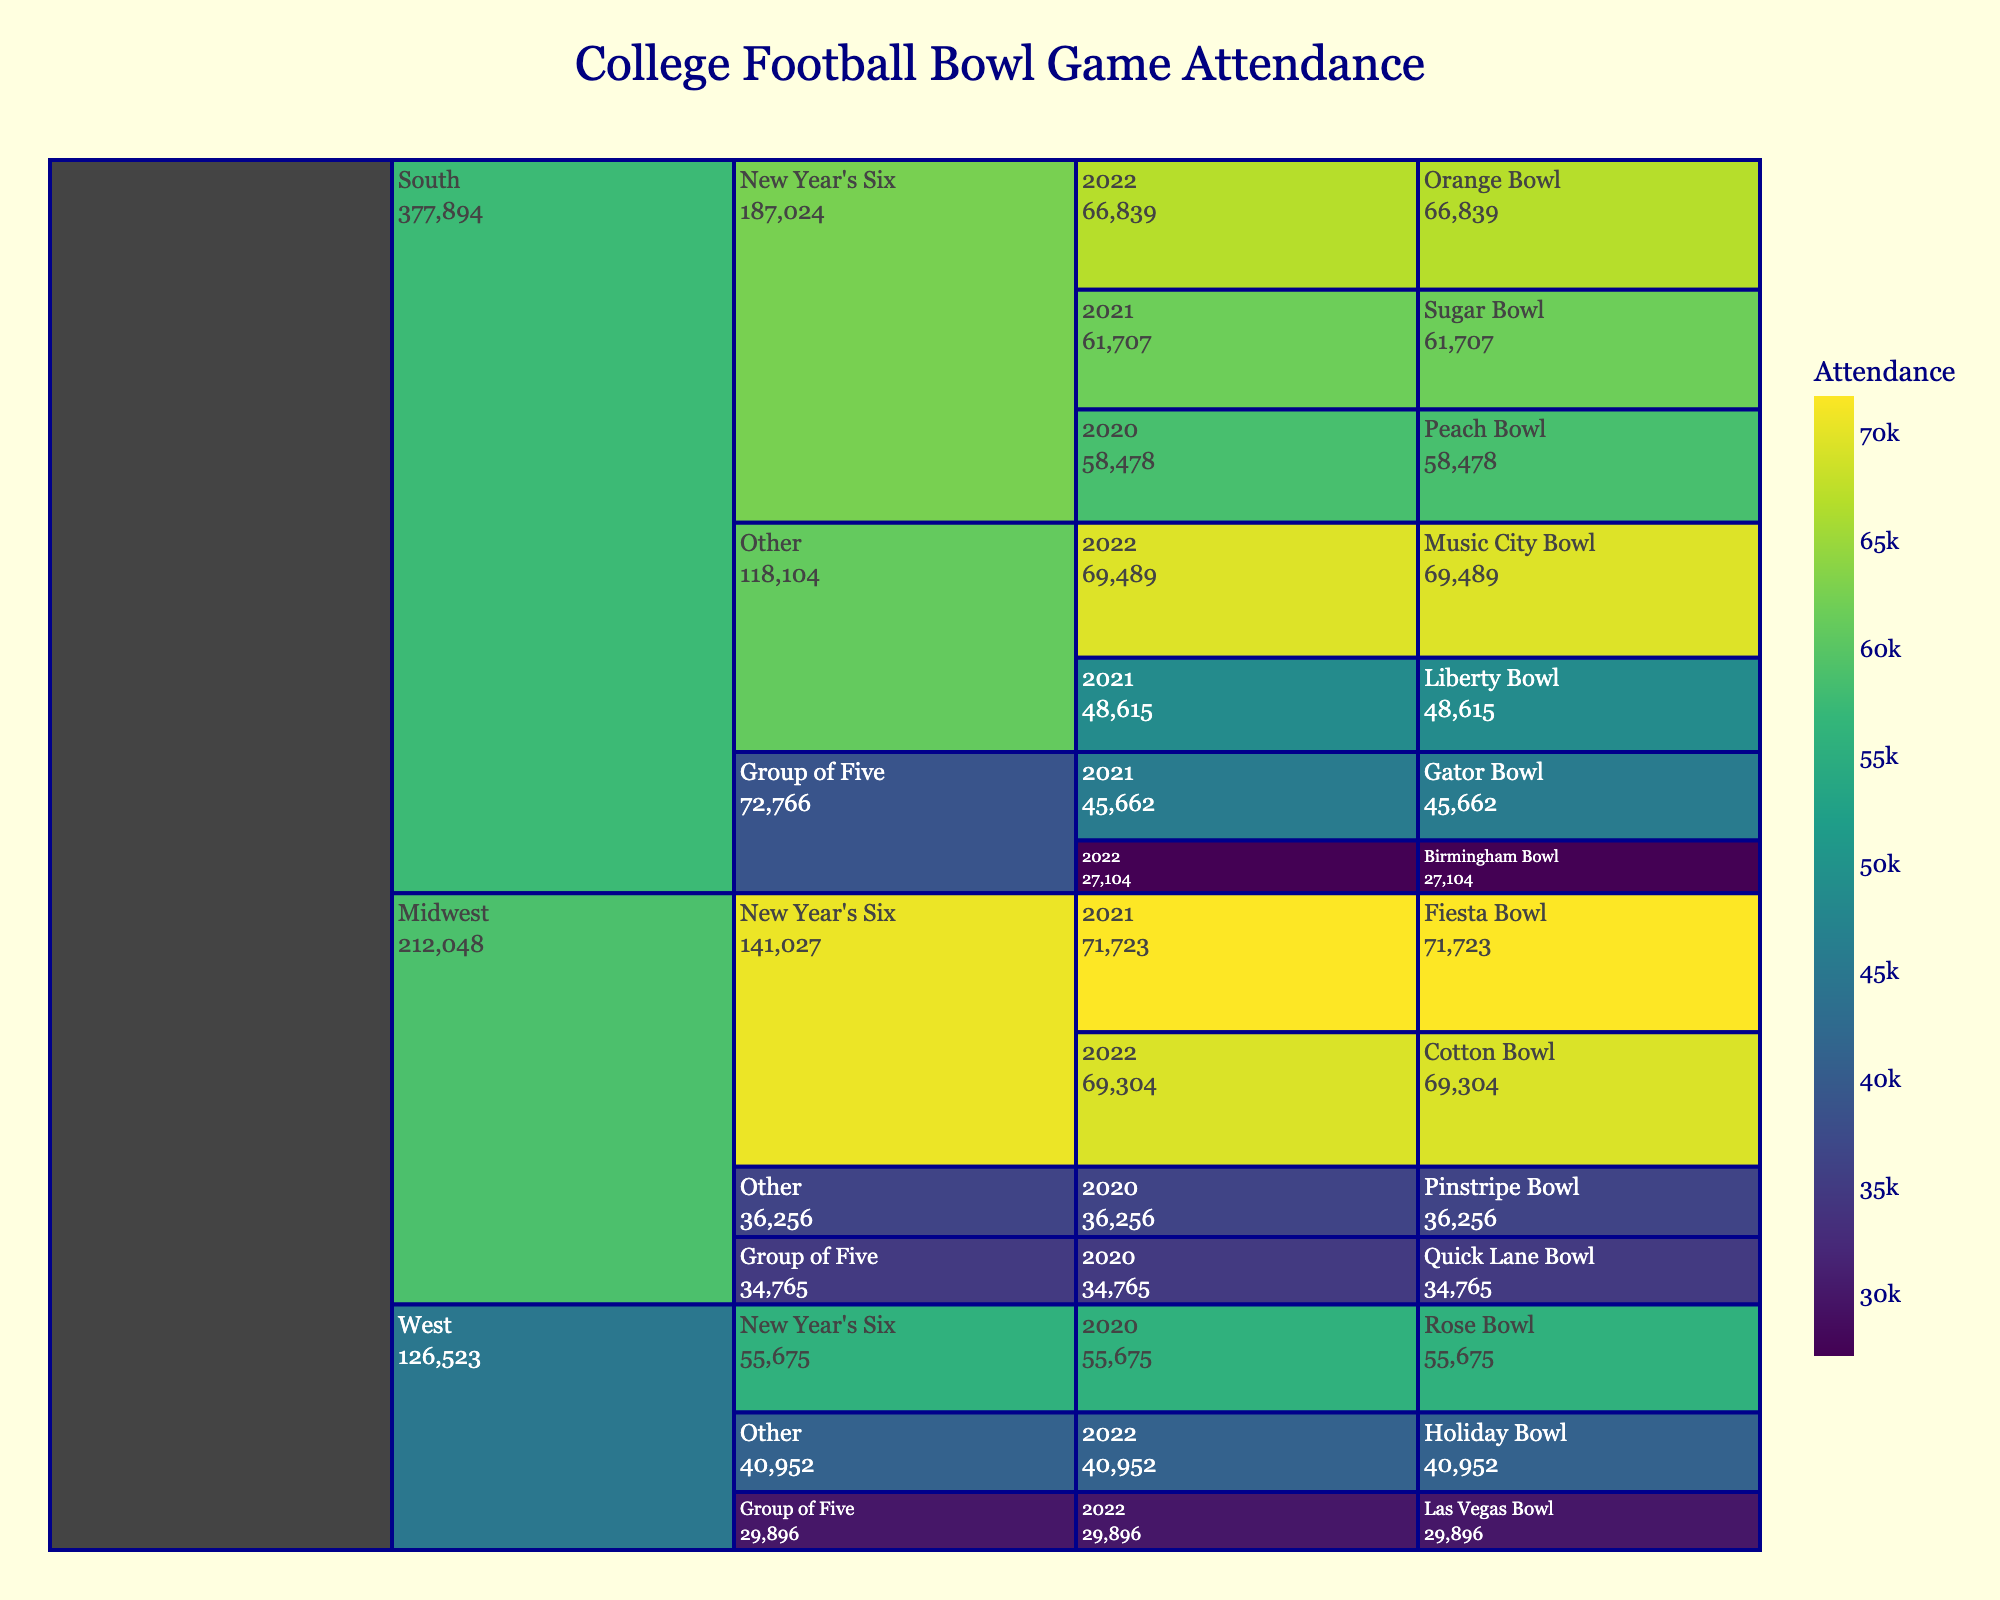what is the title of the chart? The title of the chart is provided at the top center of the figure.
Answer: College Football Bowl Game Attendance What’s the color theme used in the icicle chart for representing attendance? The icicle chart uses a continuous color scale ranging from lighter to darker shades of the Viridis color palette to represent attendance.
Answer: Viridis Which bowl had the highest attendance in 2022 New Year's Six tier in the South region? To find the highest attendance in 2022 for the New Year's Six tier in the South region, look at each bowl game under this category and compare their attendance figures. The Orange Bowl has the highest attendance with 66,839.
Answer: Orange Bowl What was the total attendance for all bowl games in the Midwest region for 2020? To find the total attendance, sum the attendance values for each bowl game in the Midwest region for the year 2020. These bowls are the Quick Lane Bowl with 34,765 and the Pinstripe Bowl with 36,256. Adding these up gives 34,765 + 36,256 = 71,021.
Answer: 71,021 How does the attendance of the 2021 Sugar Bowl compare to the 2022 Cotton Bowl? To compare these two, check the attendance values. The Sugar Bowl in 2021 had an attendance of 61,707, while the Cotton Bowl in 2022 had an attendance of 69,304. The Cotton Bowl in 2022 had a higher attendance than the Sugar Bowl in 2021.
Answer: The 2022 Cotton Bowl had higher attendance What is the average attendance for the New Year's Six bowls in 2021 across all regions? To calculate the average attendance, add up the attendance figures for all New Year's Six bowls in 2021 and divide by the number of bowls. The bowls are Sugar Bowl (61,707) and Fiesta Bowl (71,723). Adding these figures gives 61,707 + 71,723 = 133,430. There are 2 bowls, so the average is 133,430 / 2 = 66,715.
Answer: 66,715 Among the 'Other' tier bowls, which bowl had the lowest attendance in 2022? To find the bowl with the lowest attendance in the 'Other' tier for 2022, look at the attendance figures for this category. The bowls are Music City Bowl (69,489) and Holiday Bowl (40,952). The Holiday Bowl has the lowest attendance with 40,952.
Answer: Holiday Bowl Which region had the highest total attendance for Group of Five bowls in 2022? To identify this, sum the attendance for Group of Five bowls in each region for the year 2022. South: Birmingham Bowl (27,104). West: Las Vegas Bowl (29,896). Adding these values gives: 27,104 (South) compared to 29,896 (West). Hence, the West region had a higher total attendance.
Answer: West In the West region, did the Holiday Bowl or Las Vegas Bowl have a higher attendance in 2022? Compare the attendance figures for the two bowls in 2022. The Holiday Bowl had an attendance of 40,952, while the Las Vegas Bowl had 29,896. The Holiday Bowl had a higher attendance.
Answer: Holiday Bowl What is the most common color range indicating the attendance on the color scale? The color range dominantly visible spans from lighter to moderately dark shades of the Viridis color scale, indicating moderate attendance figures around the middle of the spectrum.
Answer: Moderate attendance 